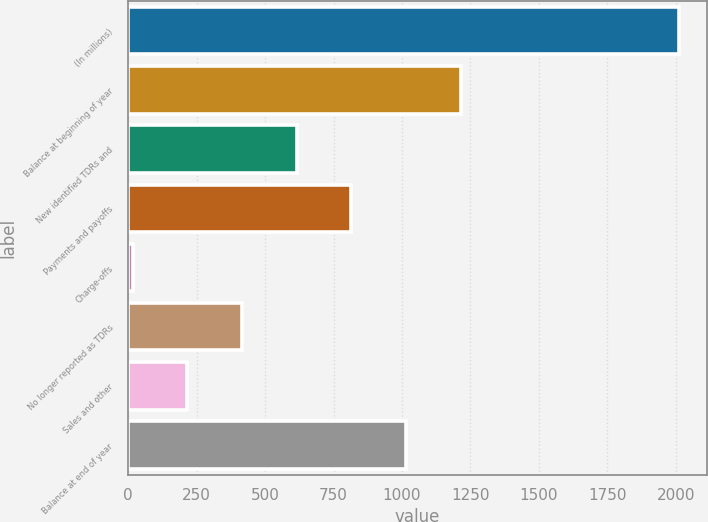Convert chart. <chart><loc_0><loc_0><loc_500><loc_500><bar_chart><fcel>(In millions)<fcel>Balance at beginning of year<fcel>New identified TDRs and<fcel>Payments and payoffs<fcel>Charge-offs<fcel>No longer reported as TDRs<fcel>Sales and other<fcel>Balance at end of year<nl><fcel>2014<fcel>1214.8<fcel>615.4<fcel>815.2<fcel>16<fcel>415.6<fcel>215.8<fcel>1015<nl></chart> 